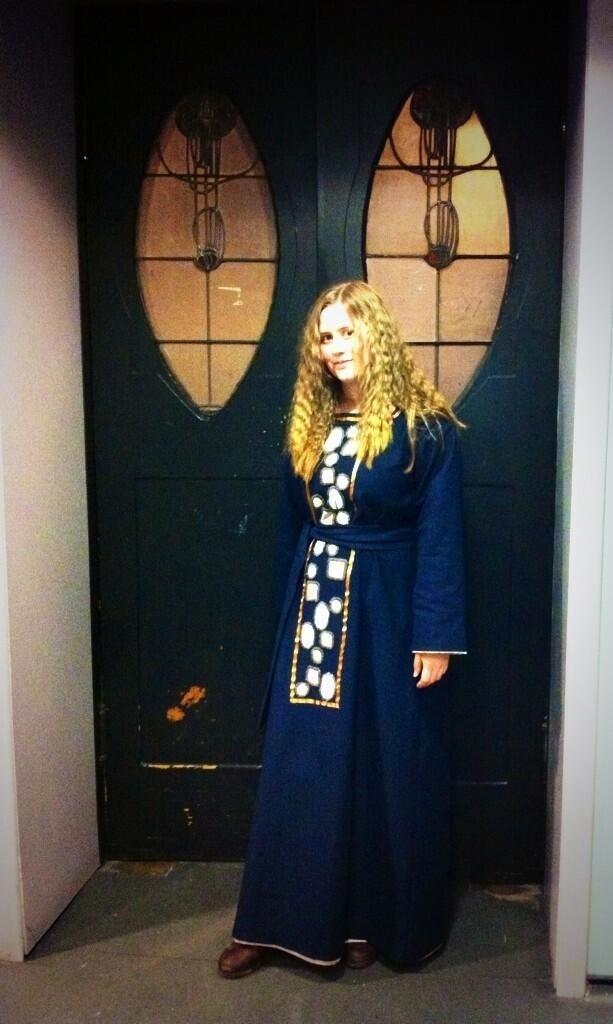How would you summarize this image in a sentence or two? There is a woman standing and smiling and we can see wall,behind this woman we can see door with glass. 